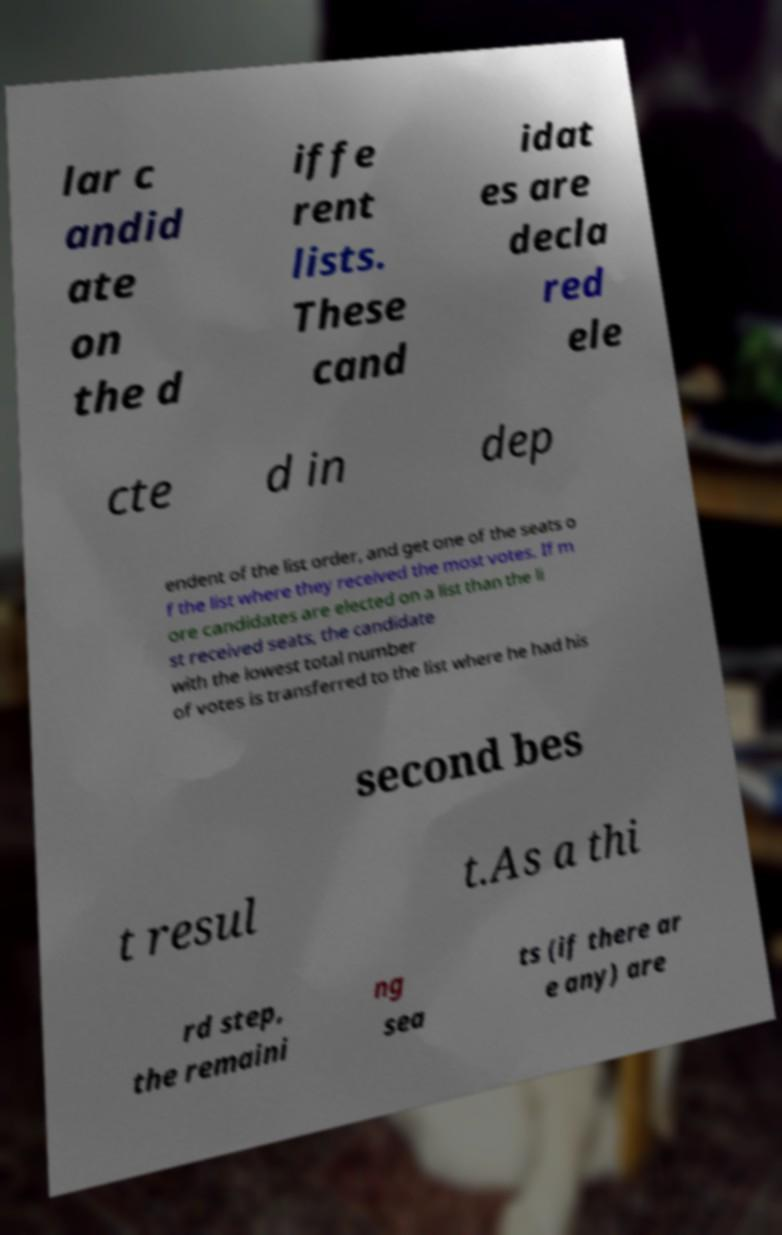What messages or text are displayed in this image? I need them in a readable, typed format. lar c andid ate on the d iffe rent lists. These cand idat es are decla red ele cte d in dep endent of the list order, and get one of the seats o f the list where they received the most votes. If m ore candidates are elected on a list than the li st received seats, the candidate with the lowest total number of votes is transferred to the list where he had his second bes t resul t.As a thi rd step, the remaini ng sea ts (if there ar e any) are 